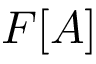<formula> <loc_0><loc_0><loc_500><loc_500>F [ A ]</formula> 